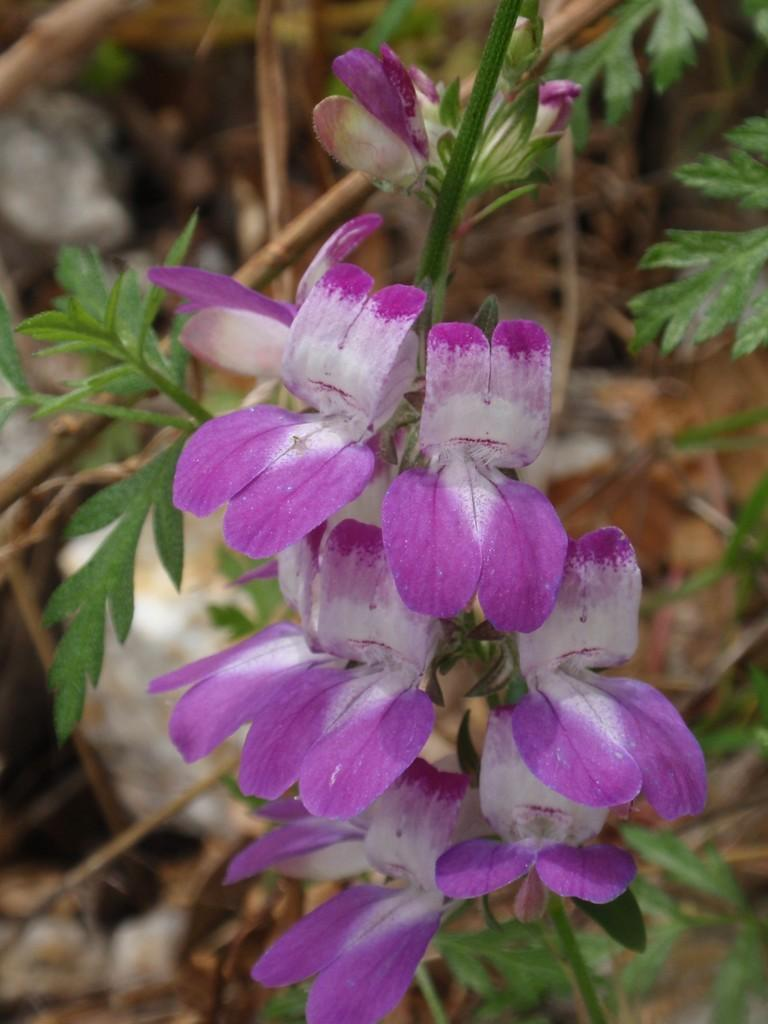What type of plant life is present in the image? There are flowers, stems, and leaves in the image. Can you describe the individual components of the plants in the image? The flowers are the colorful parts of the plants, the stems are the long, thin structures that support the flowers, and the leaves are the flat, green parts that help the plants absorb sunlight. How many hills can be seen in the image? There are no hills present in the image; it features plant life with flowers, stems, and leaves. 